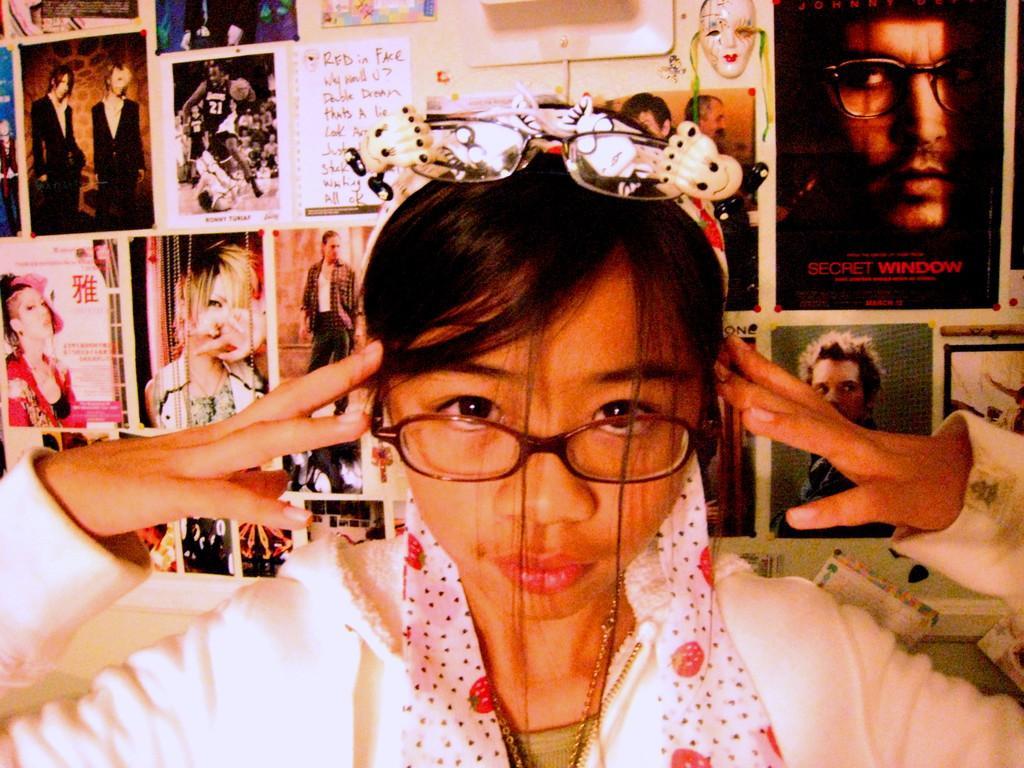In one or two sentences, can you explain what this image depicts? In this image we can see a person. On the person head we can see a spectacle. Behind the person we can see a wall. On the wall there are groups of photos of the persons and we can see a paper with text. 